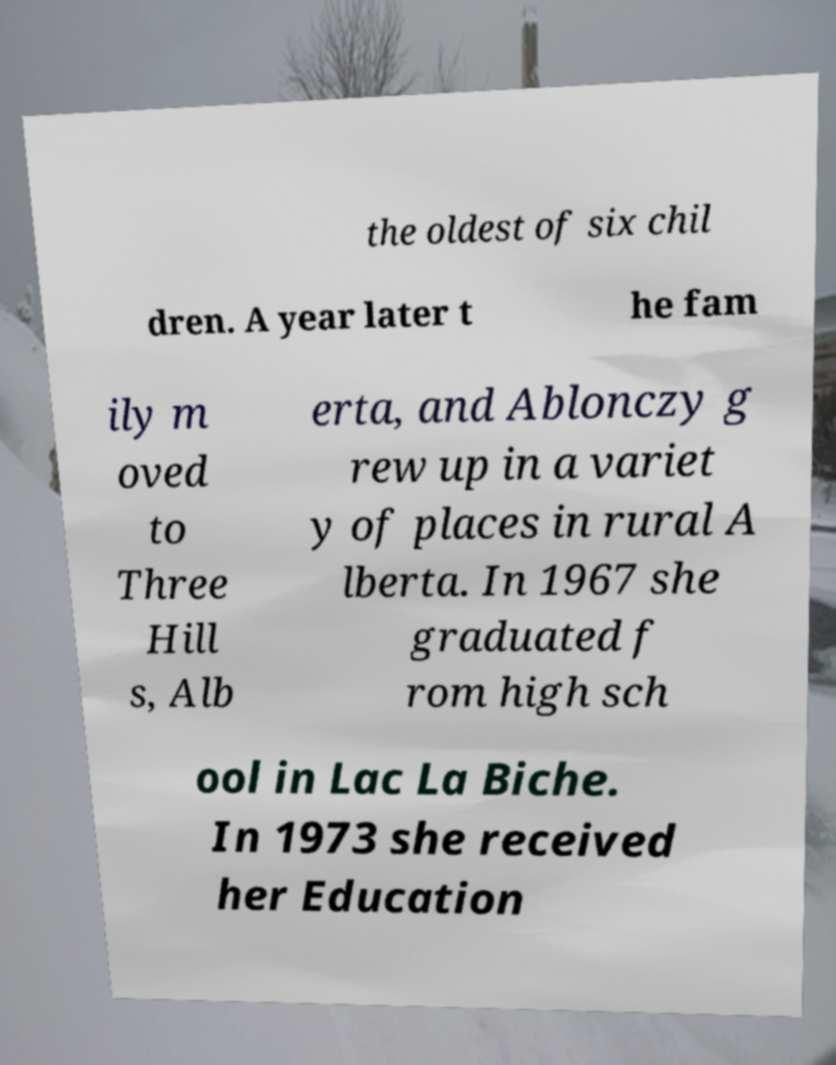Can you accurately transcribe the text from the provided image for me? the oldest of six chil dren. A year later t he fam ily m oved to Three Hill s, Alb erta, and Ablonczy g rew up in a variet y of places in rural A lberta. In 1967 she graduated f rom high sch ool in Lac La Biche. In 1973 she received her Education 